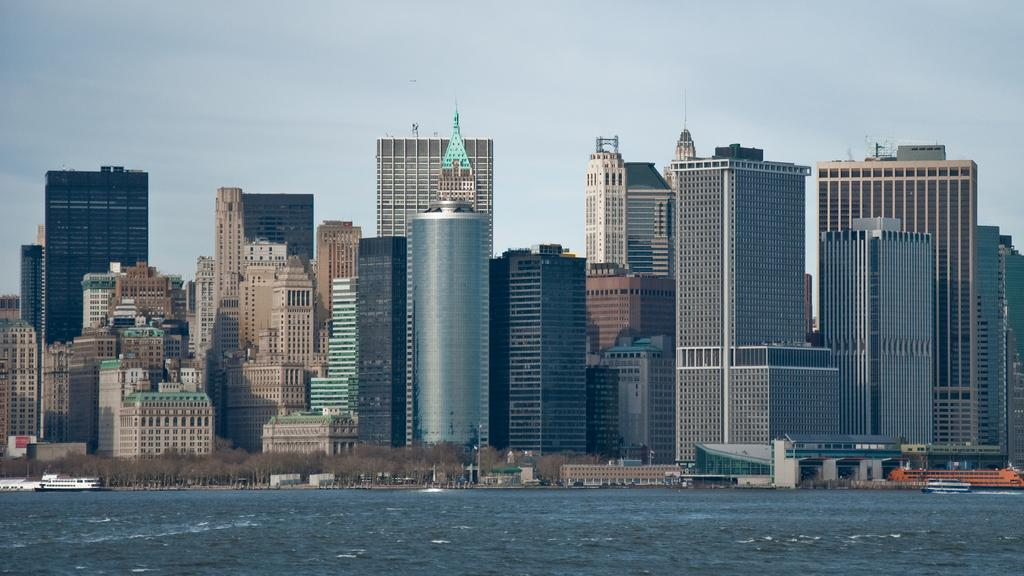What is located in the foreground of the image? There is a water body in the foreground of the image. What can be seen in the middle of the image? There are trees, boats, and buildings in the middle of the image. What is visible at the top of the image? The sky is visible at the top of the image. What type of lettuce can be seen growing near the water body in the image? There is no lettuce present in the image; it features a water body, trees, boats, buildings, and the sky. What nut is being used to anchor the boats in the image? There is no nut present in the image; the boats are not anchored by any visible nuts. 